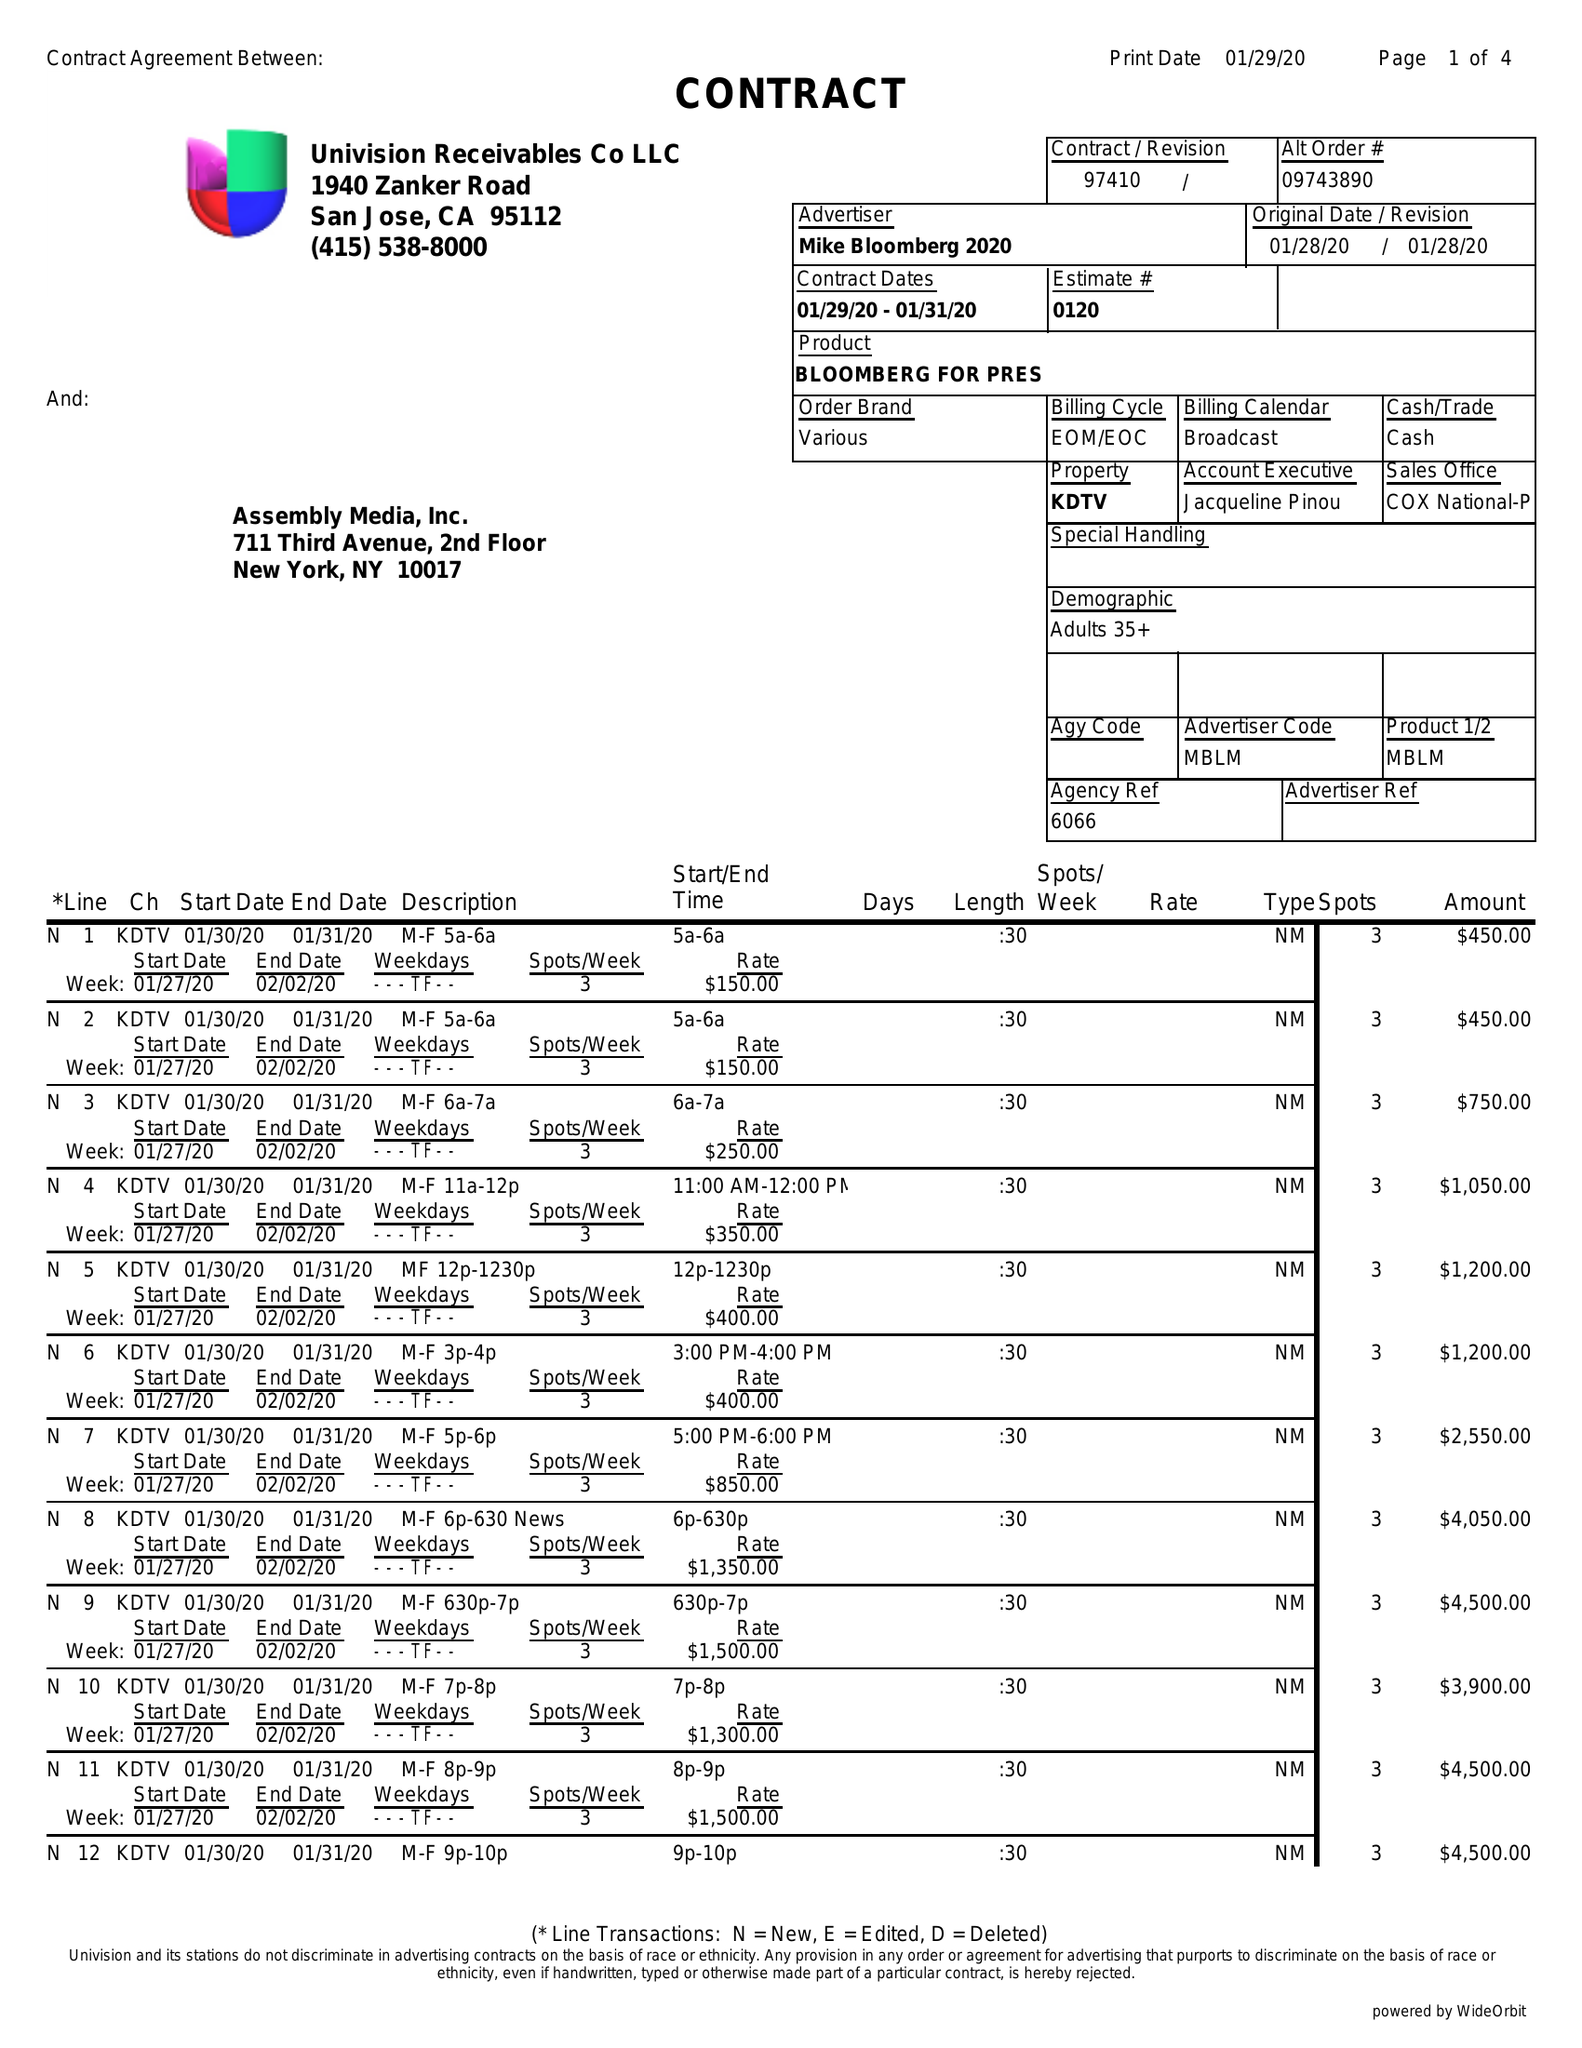What is the value for the contract_num?
Answer the question using a single word or phrase. 97410 